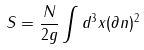<formula> <loc_0><loc_0><loc_500><loc_500>S = \frac { N } { 2 g } \int d ^ { 3 } x ( \partial n ) ^ { 2 }</formula> 